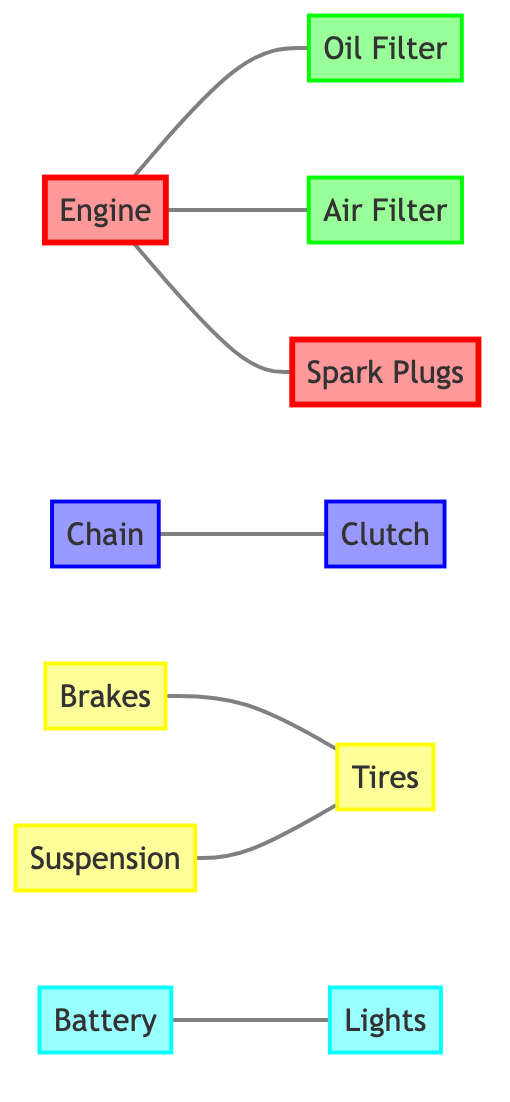What is the total number of nodes in the graph? The graph contains a list of nodes. By counting the nodes in the provided data, we see that there are 11 nodes listed: Engine, Oil Filter, Air Filter, Spark Plugs, Chain, Brakes, Clutch, Tires, Battery, Suspension, and Lights.
Answer: 11 What is the relationship between the Engine and the Oil Filter? The diagram indicates that the Engine is connected to the Oil Filter, which means they share a direct relationship. This can be seen from the edge that connects these two nodes in the data.
Answer: connected Which two components share a direct connection with the Tires? Looking at the edges connected to the Tires, we find two components: Brakes and Suspension. Each of these components has a direct edge linking back to the Tires in the graph.
Answer: Brakes, Suspension How many edges are present in the diagram? To determine the number of edges, we need to count the connections specified in the data. There are 7 edges detailed: Engine-Oil Filter, Engine-Air Filter, Engine-Spark Plugs, Chain-Clutch, Brakes-Tires, Suspension-Tires, Battery-Lights. Therefore, the total is 7.
Answer: 7 What is the main system that all other parts depend on? Analyzing the connections in the diagram, the Engine is the only component that has multiple direct connections to other components, indicating that it serves as the central part that most other systems depend upon.
Answer: Engine Which parts are dependent on the Battery? The edges indicate that the Battery is connected to the Lights, which means that Lights depend on the Battery for operation, establishing a direct connection between these two parts.
Answer: Lights What can be inferred about the relationship between Chain and Clutch? The Chain and Clutch are directly connected, indicating that they are likely components of the drivetrain system that function together. Therefore, the relationship can be inferred as interdependent and coordinated in operation.
Answer: connected What type of maintenance do the Brakes and Tires relate to? Since both the Brakes and Tires are classified under the safety category in the graph, the maintenance for these components can be inferred as safety maintenance, crucial for the motorcycle's operation and rider safety.
Answer: safety maintenance Which part is most likely to affect the performance of the Engine regarding maintenance? Based on the relationships shown, the Oil Filter, Air Filter, and Spark Plugs are all directly linked to the Engine. If maintenance on any of these components is neglected, it could significantly affect Engine performance.
Answer: Oil Filter, Air Filter, Spark Plugs 